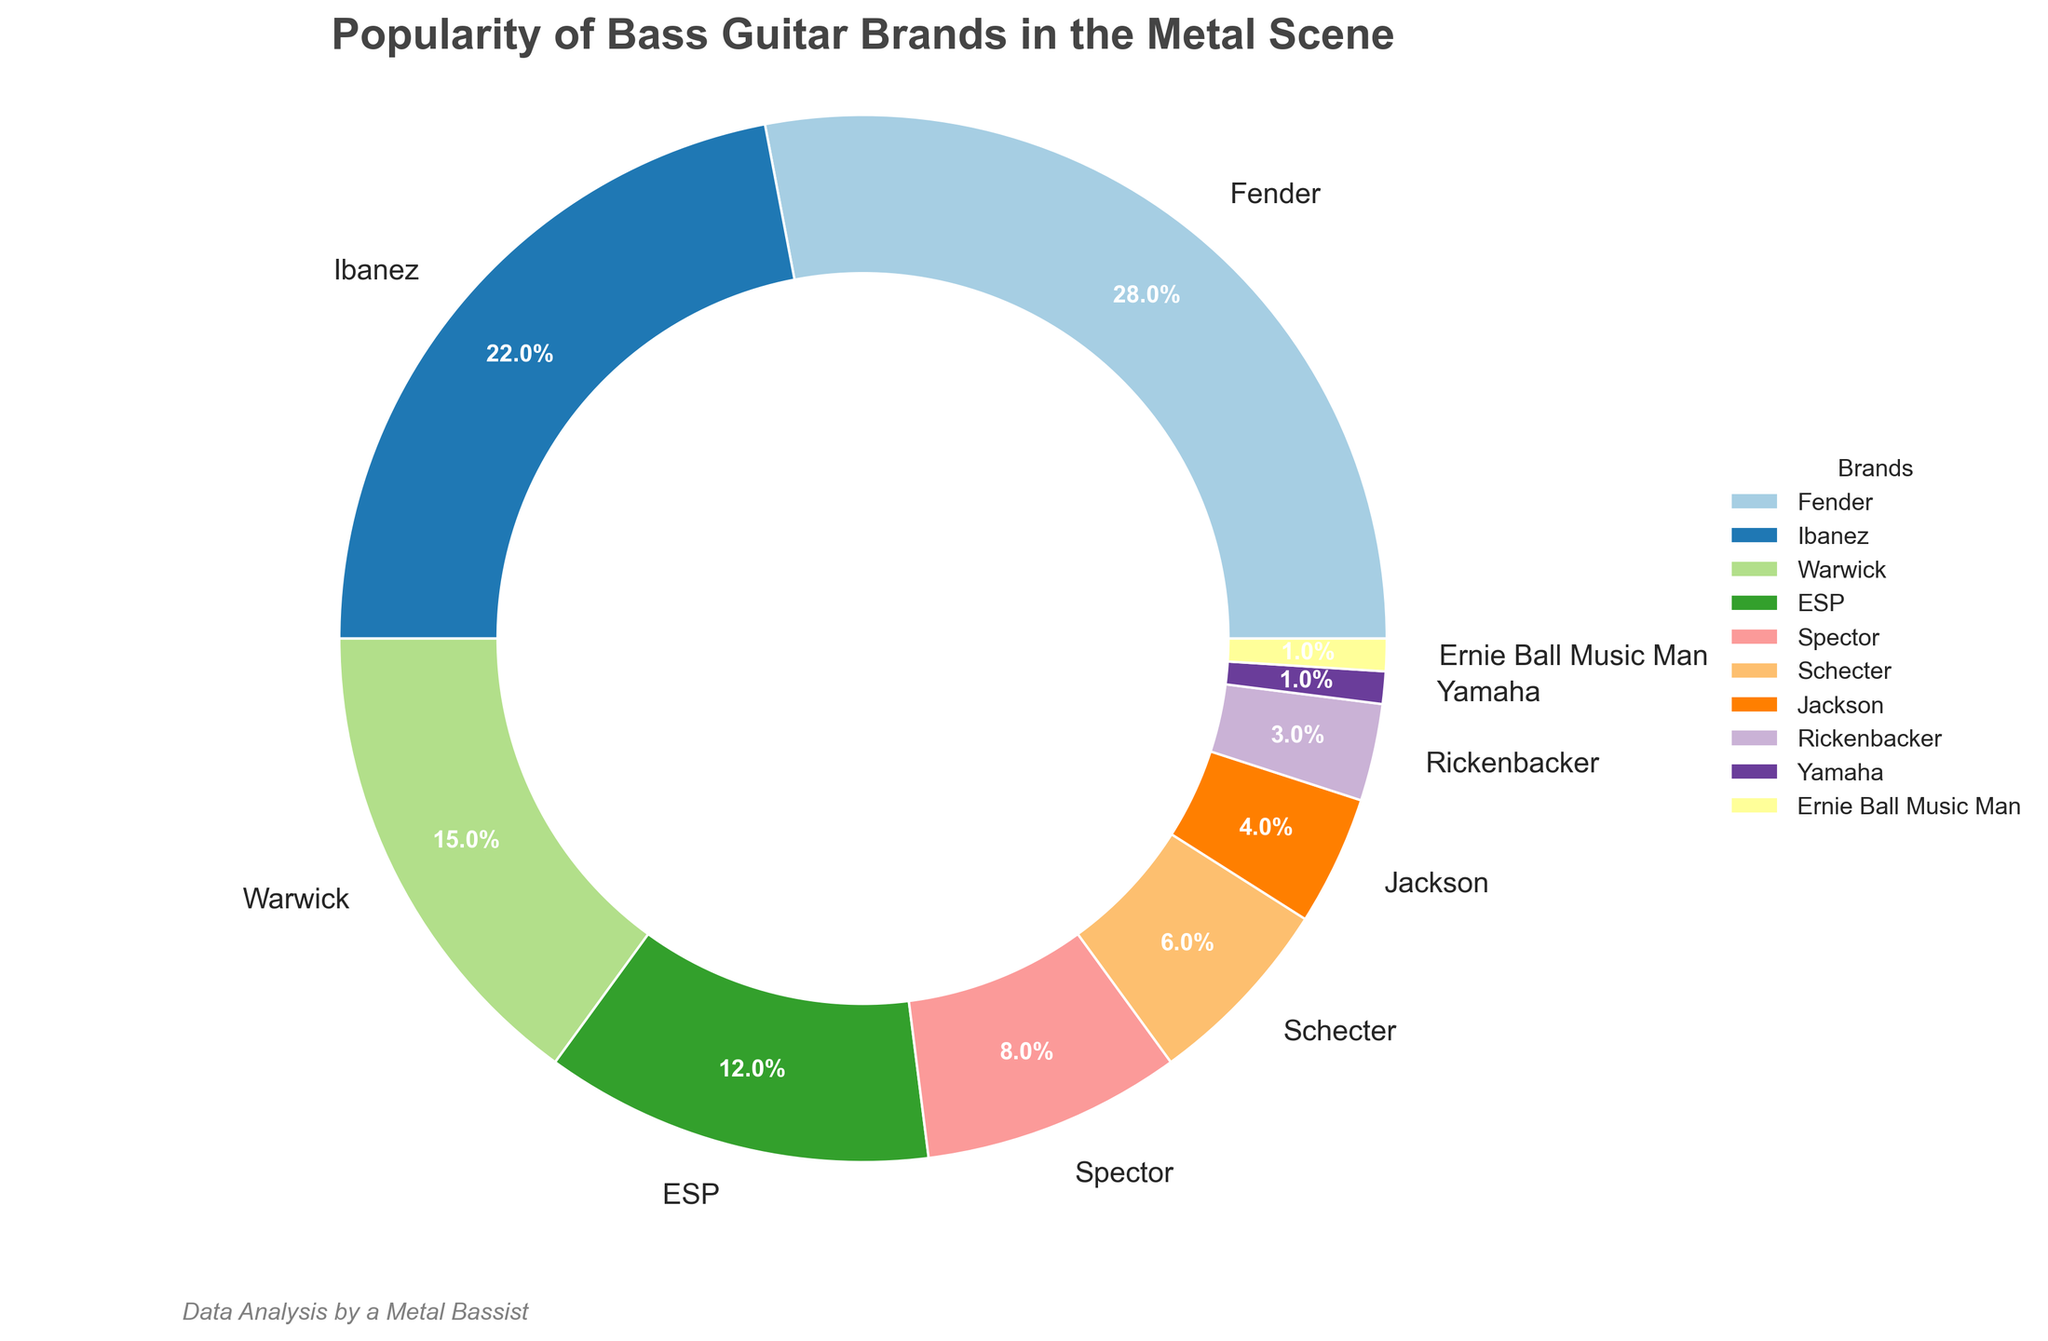Which bass guitar brand is the most popular in the metal scene? By looking at the chart, identify the brand with the largest percentage. The largest segment corresponds to Fender with 28%.
Answer: Fender What is the total percentage of popularity for Ibanez and ESP combined? Add the percentages for Ibanez (22%) and ESP (12%). 22 + 12 = 34.
Answer: 34% Which brand has a higher popularity, Jackson or Rickenbacker? Compare the percentages of Jackson (4%) and Rickenbacker (3%). Jackson has a higher percentage.
Answer: Jackson Which two brands have the smallest popularity percentages? Identify the brands with the smallest segments. The smallest segments correspond to Yamaha and Ernie Ball Music Man, both at 1%.
Answer: Yamaha and Ernie Ball Music Man What is the difference in popularity percentages between Warwick and Schecter? Subtract the percentage of Schecter (6%) from the percentage of Warwick (15%). 15 - 6 = 9.
Answer: 9% If the brands Spector and Jackson were combined into one segment, what would be their total percentage? Add the percentages for Spector (8%) and Jackson (4%). 8 + 4 = 12.
Answer: 12% Which color is used to represent the brand ESP in the pie chart? Look at the color legend in the pie chart for ESP. The specific color might vary but it would be represented by a distinct color as seen in the wedges.
Answer: Varies How many brands have a popularity percentage that is 10% or higher? Count the segments with percentages 10% or higher: Fender (28%), Ibanez (22%), Warwick (15%), and ESP (12%). There are 4 such brands.
Answer: 4 Which brand is less popular than Warwick but more popular than Schecter? Warwick has 15% and Schecter has 6%, so find the brand between them. Spector fits at 8%.
Answer: Spector What percentage of the chart is occupied by brands other than the top two brands? The top two brands are Fender (28%) and Ibanez (22%), giving a combined percentage of 50%. Subtract this from 100%. 100 - 50 = 50.
Answer: 50% 